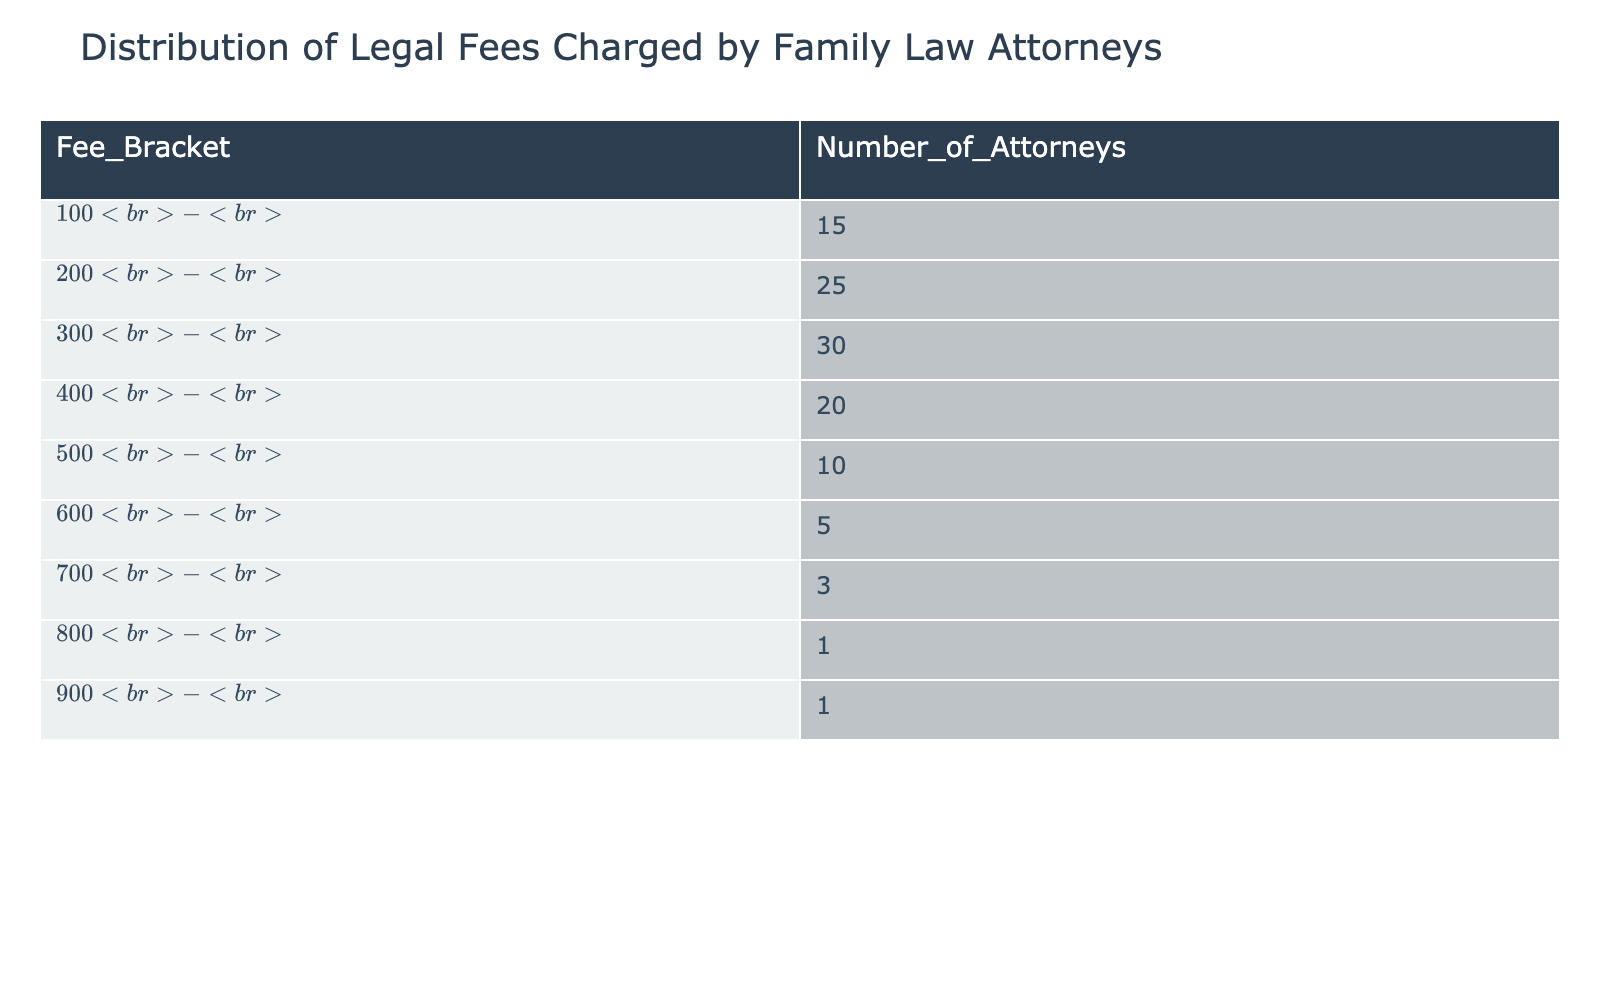What is the fee bracket with the highest number of attorneys? Looking at the 'Number_of_Attorneys' column, the fee bracket '$200 - $299' has the highest count of 25 attorneys.
Answer: $200 - $299 How many attorneys charge fees of $600 or more? We can find the total number of attorneys in the fee brackets '$600 - $699', '$700 - $799', '$800 - $899', and '$900 - $999', which are 5 + 3 + 1 + 1 = 10.
Answer: 10 What is the total number of attorneys represented in the table? To find the total, we sum the 'Number_of_Attorneys' across all fee brackets: 15 + 25 + 30 + 20 + 10 + 5 + 3 + 1 + 1 = 110.
Answer: 110 Is there any attorney that charges $800 or more? Yes, there are attorneys in the $800 - $899 and $900 - $999 fee brackets, which indicates that the answer is affirmative.
Answer: Yes What is the average fee charged by attorneys in the $300 - $399 bracket? Since the 'Number_of_Attorneys' in the $300 - $399 bracket is 30, the average fee is calculated as (300 + 399) / 2 = 349.5.
Answer: 349.5 Which fee bracket has the least representation of attorneys? By looking at the 'Number_of_Attorneys', the fee bracket '$800 - $899' has only 1 attorney.
Answer: $800 - $899 What percentage of attorneys charge between $100 - $399? First, we add the number of attorneys in the $100 - $199, $200 - $299, and $300 - $399 brackets: 15 + 25 + 30 = 70. We then divide by the total number of attorneys (110) and multiply by 100, so (70 / 110) * 100 = 63.64%.
Answer: 63.64% Are there more attorneys charging between $400 - $499 than those charging between $600 - $699? Comparing the numbers, there are 20 attorneys in the $400 - $499 bracket and 5 in the $600 - $699 bracket. Since 20 is greater than 5, the answer is affirmative.
Answer: Yes What is the difference in the number of attorneys between the $500 - $599 and the $700 - $799 brackets? The $500 - $599 bracket has 10 attorneys, while the $700 - $799 bracket has 3 attorneys. The difference is 10 - 3 = 7.
Answer: 7 